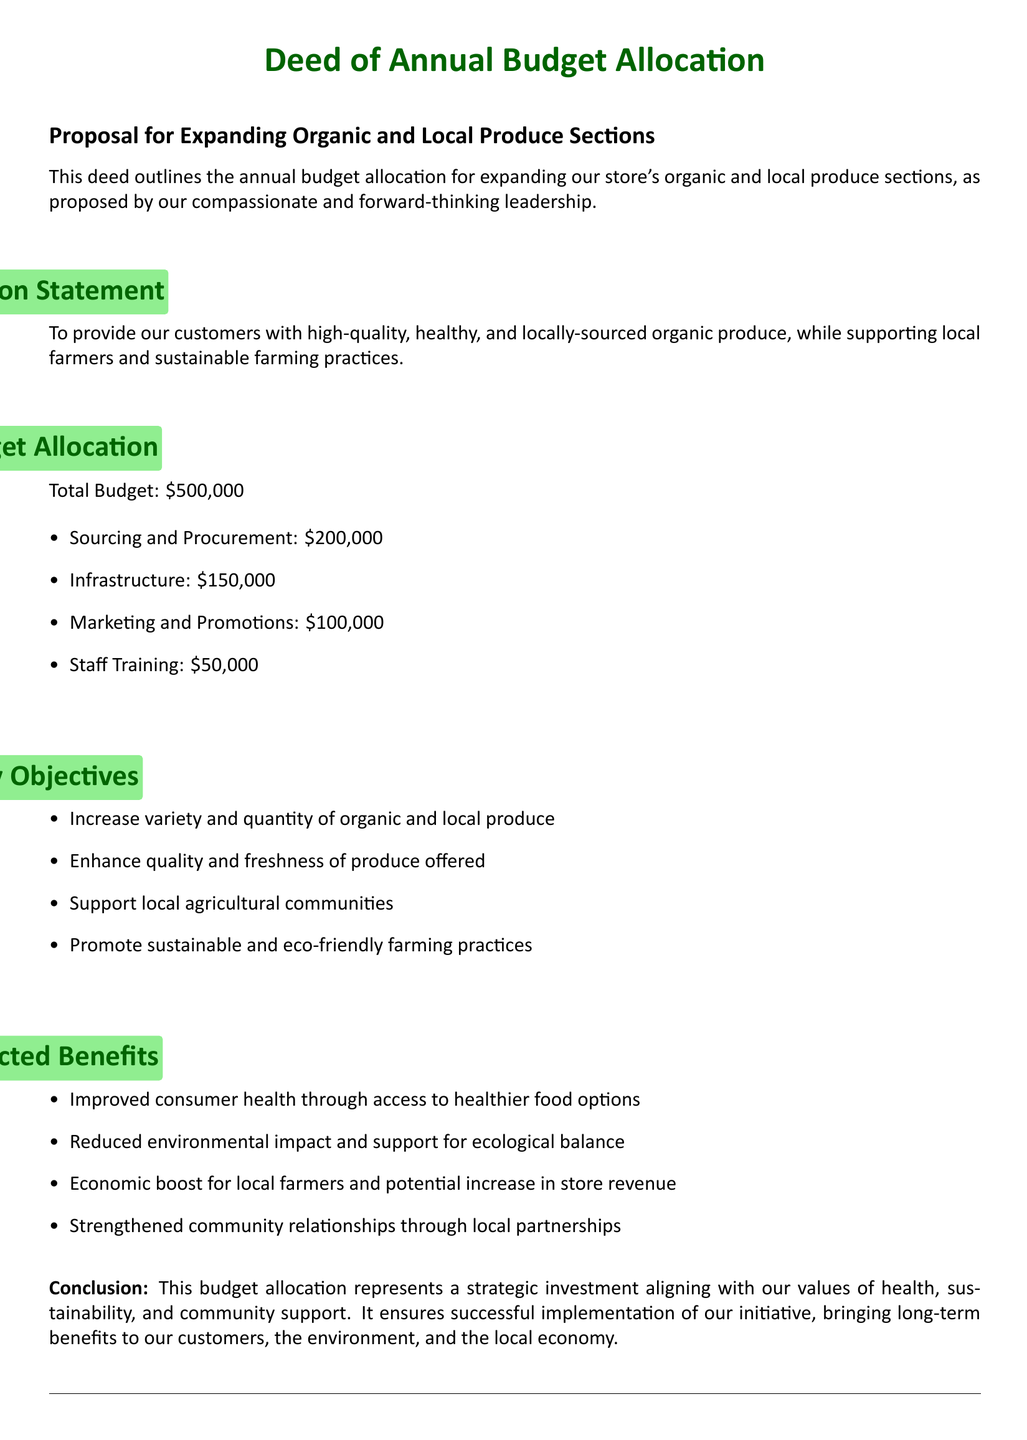What is the total budget for the allocation? The total budget is stated in the document as the overall amount for this proposal.
Answer: $500,000 How much is allocated for sourcing and procurement? This figure is specified as part of the budget allocation section.
Answer: $200,000 What is one of the key objectives mentioned in the deed? This is found in the key objectives section and highlights important goals of the proposal.
Answer: Increase variety and quantity of organic and local produce What is the amount earmarked for staff training? The budget allocation for staff training is directly mentioned in the document.
Answer: $50,000 What benefit is expected from supporting local farmers? The document outlines expected benefits which reflect the proposal's impact on relationships.
Answer: Economic boost for local farmers What environmental commitment is highlighted in the objectives? This objective reflects a sustainable approach as stated in the document.
Answer: Promote sustainable and eco-friendly farming practices When is the deed proposed to be signed? The document specifies a placeholder for the date of signing.
Answer: day of What is the mission statement's focus? The mission statement outlines the general goal of the proposal as described in the document.
Answer: high-quality, healthy, and locally-sourced organic produce Who is responsible for signing the document? The document specifies the role of the person signing the deed.
Answer: Store Owner/Manager What aspect of marketing is covered in the budget allocation? The budget section indicates how much is set aside for promotional purposes.
Answer: $100,000 